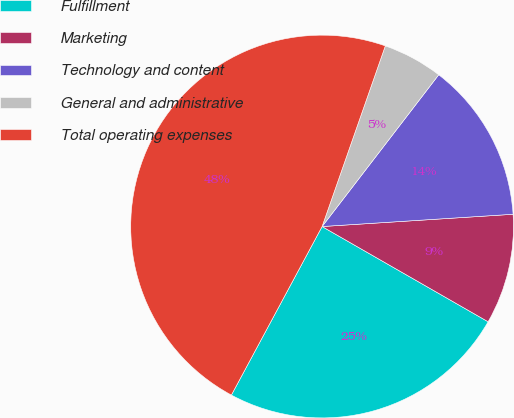<chart> <loc_0><loc_0><loc_500><loc_500><pie_chart><fcel>Fulfillment<fcel>Marketing<fcel>Technology and content<fcel>General and administrative<fcel>Total operating expenses<nl><fcel>24.57%<fcel>9.31%<fcel>13.55%<fcel>5.07%<fcel>47.5%<nl></chart> 